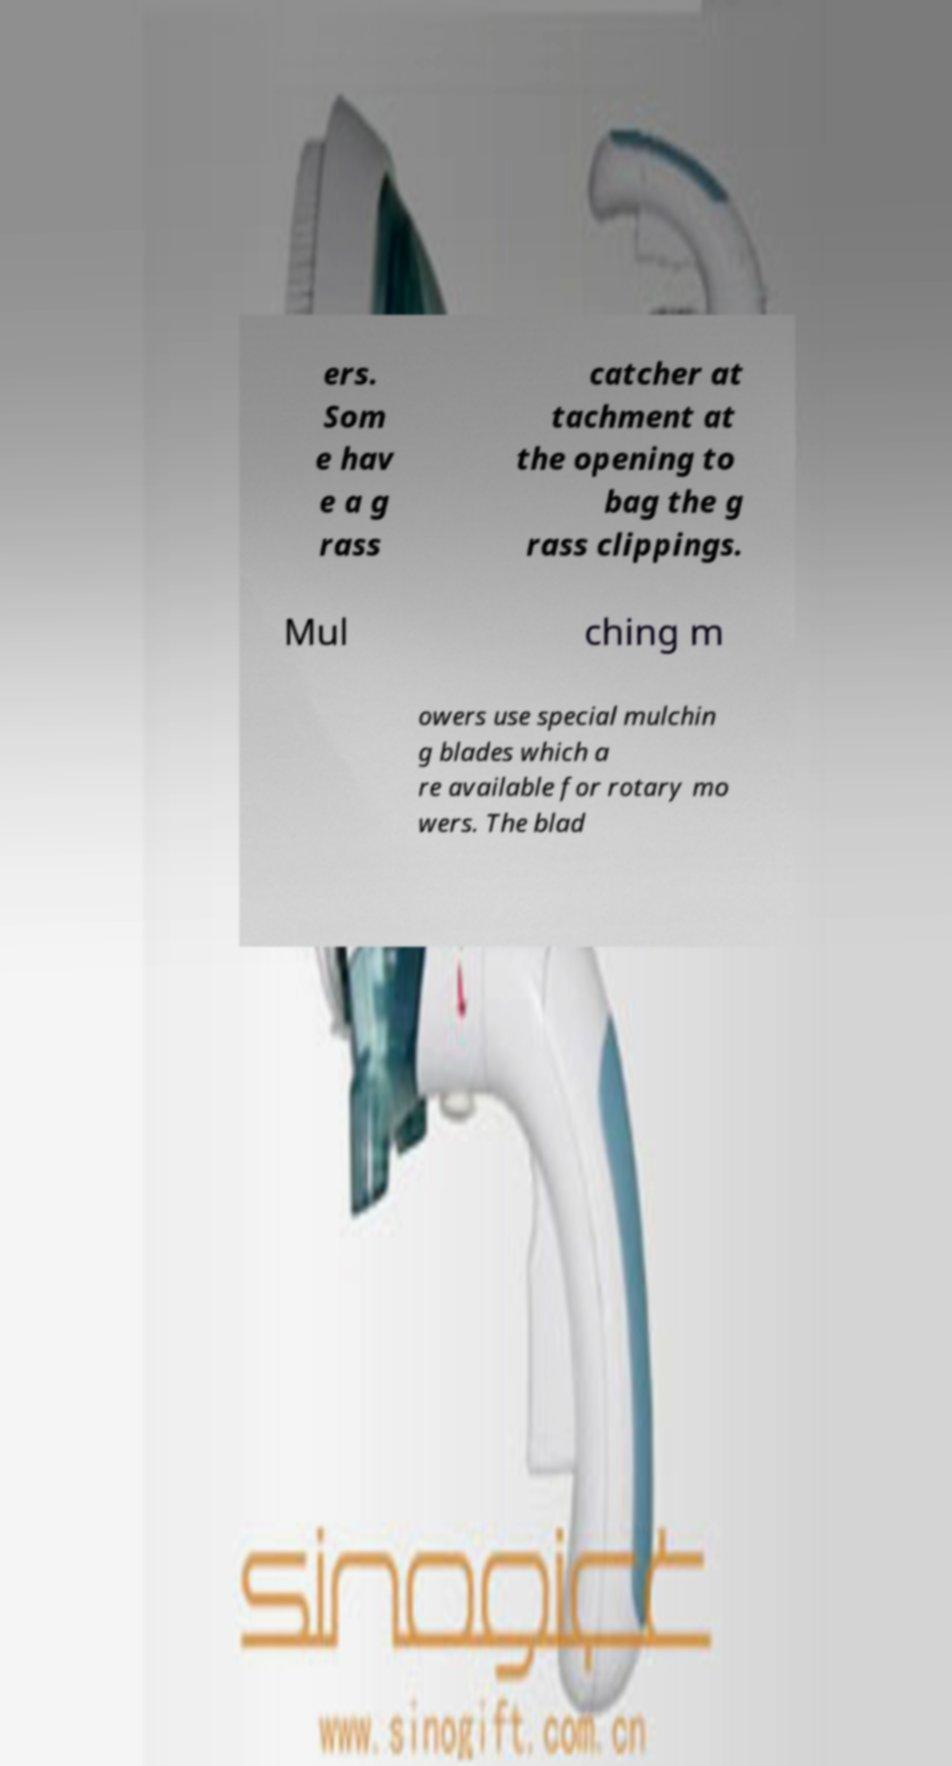There's text embedded in this image that I need extracted. Can you transcribe it verbatim? ers. Som e hav e a g rass catcher at tachment at the opening to bag the g rass clippings. Mul ching m owers use special mulchin g blades which a re available for rotary mo wers. The blad 